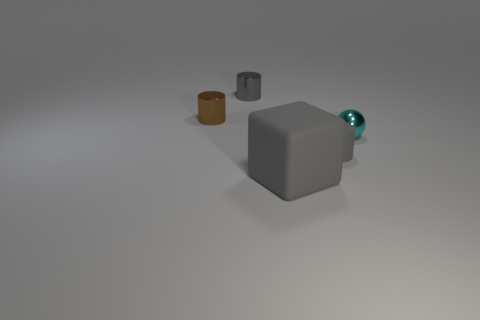Subtract all small gray cylinders. How many cylinders are left? 1 Add 4 small shiny balls. How many objects exist? 9 Subtract all gray cylinders. How many cylinders are left? 1 Subtract all cylinders. How many objects are left? 2 Subtract 3 cylinders. How many cylinders are left? 0 Subtract all red cylinders. Subtract all blue cubes. How many cylinders are left? 3 Subtract all purple spheres. How many gray cylinders are left? 2 Subtract all small yellow shiny balls. Subtract all gray shiny objects. How many objects are left? 4 Add 4 metal cylinders. How many metal cylinders are left? 6 Add 5 large things. How many large things exist? 6 